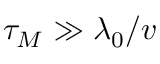<formula> <loc_0><loc_0><loc_500><loc_500>\tau _ { M } \gg \lambda _ { 0 } / v</formula> 